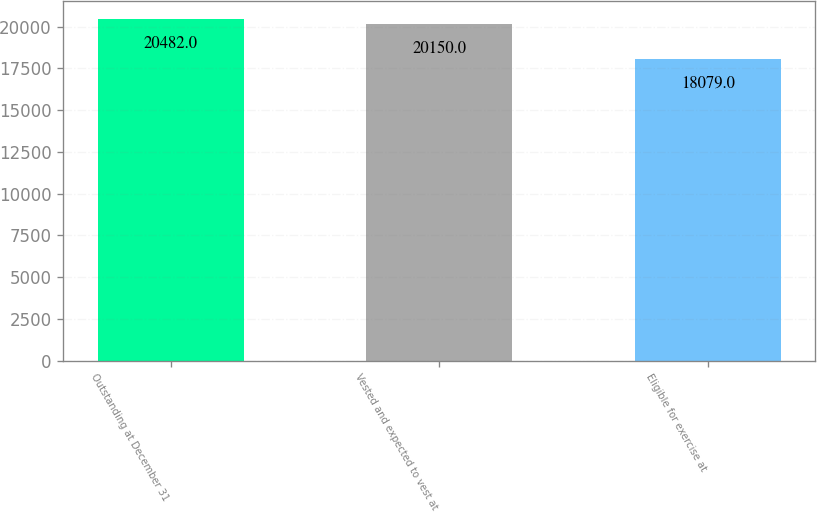Convert chart to OTSL. <chart><loc_0><loc_0><loc_500><loc_500><bar_chart><fcel>Outstanding at December 31<fcel>Vested and expected to vest at<fcel>Eligible for exercise at<nl><fcel>20482<fcel>20150<fcel>18079<nl></chart> 